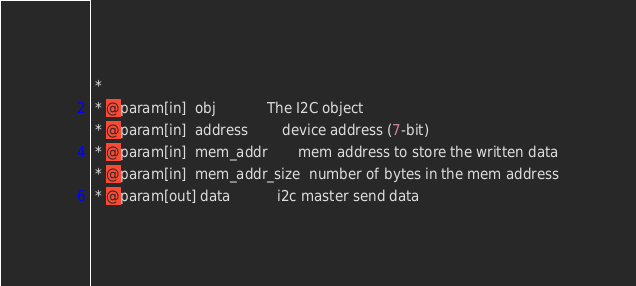<code> <loc_0><loc_0><loc_500><loc_500><_C_> *
 * @param[in]  obj            The I2C object
 * @param[in]  address        device address (7-bit)
 * @param[in]  mem_addr       mem address to store the written data
 * @param[in]  mem_addr_size  number of bytes in the mem address
 * @param[out] data           i2c master send data</code> 